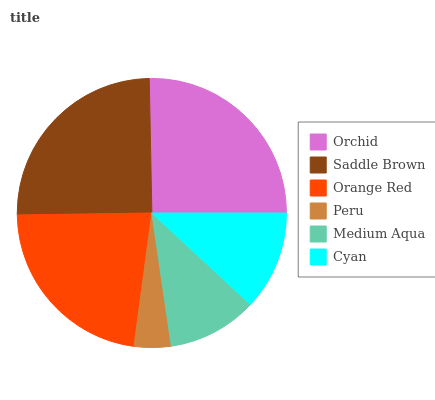Is Peru the minimum?
Answer yes or no. Yes. Is Orchid the maximum?
Answer yes or no. Yes. Is Saddle Brown the minimum?
Answer yes or no. No. Is Saddle Brown the maximum?
Answer yes or no. No. Is Orchid greater than Saddle Brown?
Answer yes or no. Yes. Is Saddle Brown less than Orchid?
Answer yes or no. Yes. Is Saddle Brown greater than Orchid?
Answer yes or no. No. Is Orchid less than Saddle Brown?
Answer yes or no. No. Is Orange Red the high median?
Answer yes or no. Yes. Is Cyan the low median?
Answer yes or no. Yes. Is Peru the high median?
Answer yes or no. No. Is Orchid the low median?
Answer yes or no. No. 